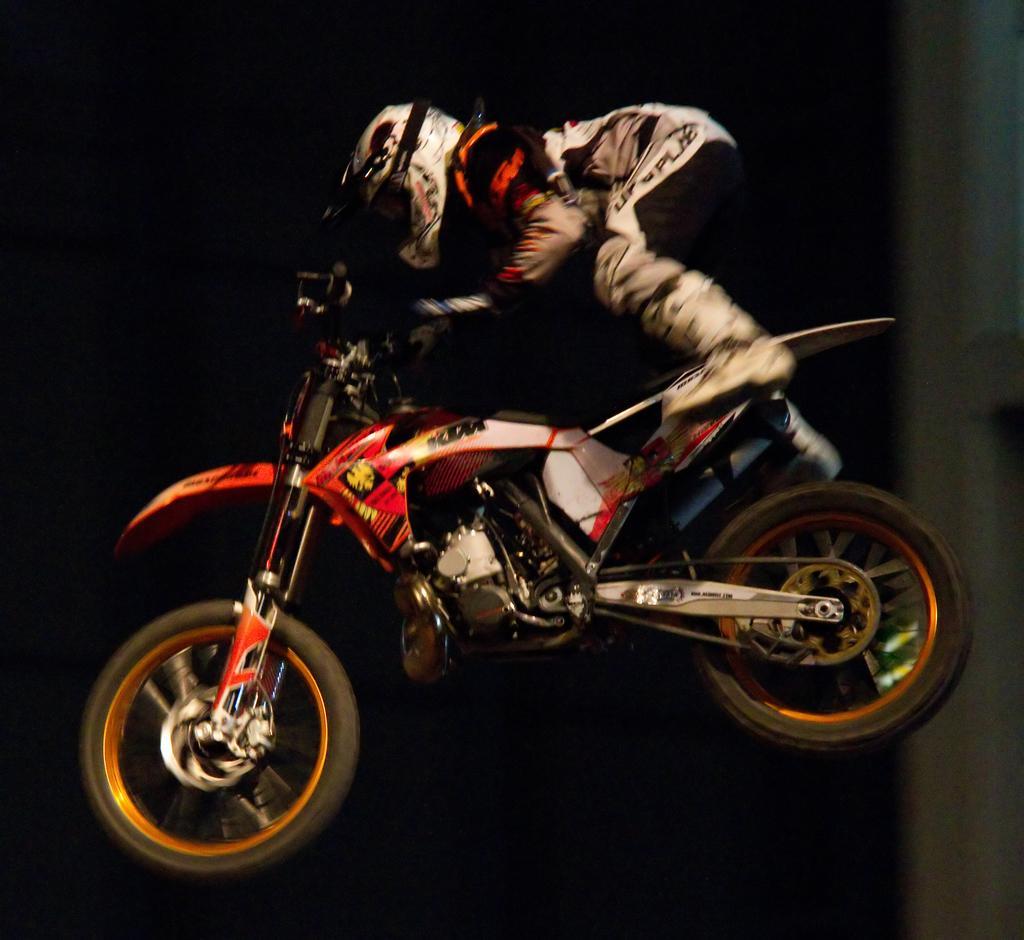In one or two sentences, can you explain what this image depicts? In this image, we can see a bike, there is a person wearing a helmet on the bike, the bike is in the air. 